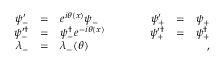<formula> <loc_0><loc_0><loc_500><loc_500>\begin{array} { r c l c r c l } { { \psi _ { - } ^ { \prime } } } & { = } & { { e ^ { i \theta ( x ) } \psi _ { - } } } & { \quad } & { { \psi _ { + } ^ { \prime } } } & { = } & { { \psi _ { + } } } \\ { { \psi _ { - } ^ { \prime \dag } } } & { = } & { { \psi _ { - } ^ { \dag } e ^ { - i \theta ( x ) } } } & { \quad } & { { \psi _ { + } ^ { \prime \dag } } } & { = } & { { \psi _ { + } ^ { \dag } } } \\ { { \lambda _ { - } } } & { = } & { { \lambda _ { - } ( \theta ) } } & { \quad , } \end{array}</formula> 